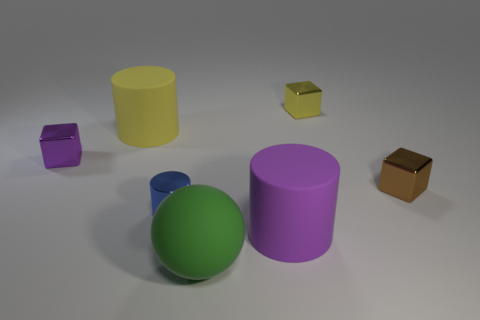Subtract 2 blocks. How many blocks are left? 1 Add 3 big purple cylinders. How many objects exist? 10 Subtract all big yellow cylinders. How many cylinders are left? 2 Subtract all blue cylinders. How many cylinders are left? 2 Subtract all cylinders. How many objects are left? 4 Subtract all purple cubes. How many purple spheres are left? 0 Subtract all large red matte spheres. Subtract all matte balls. How many objects are left? 6 Add 4 large green matte spheres. How many large green matte spheres are left? 5 Add 6 rubber objects. How many rubber objects exist? 9 Subtract 0 blue cubes. How many objects are left? 7 